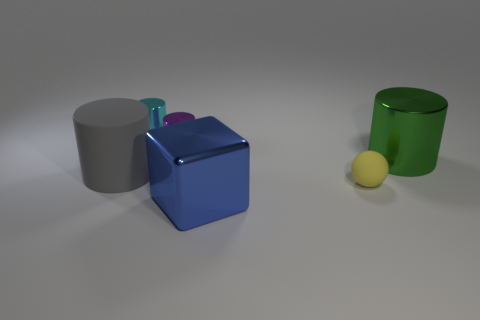What time of day does the lighting in the image suggest? The lighting in the image does not strongly indicate a specific time of day as it appears to be a controlled studio setting with artificial lighting, characterized by soft shadows and a neutral background. 